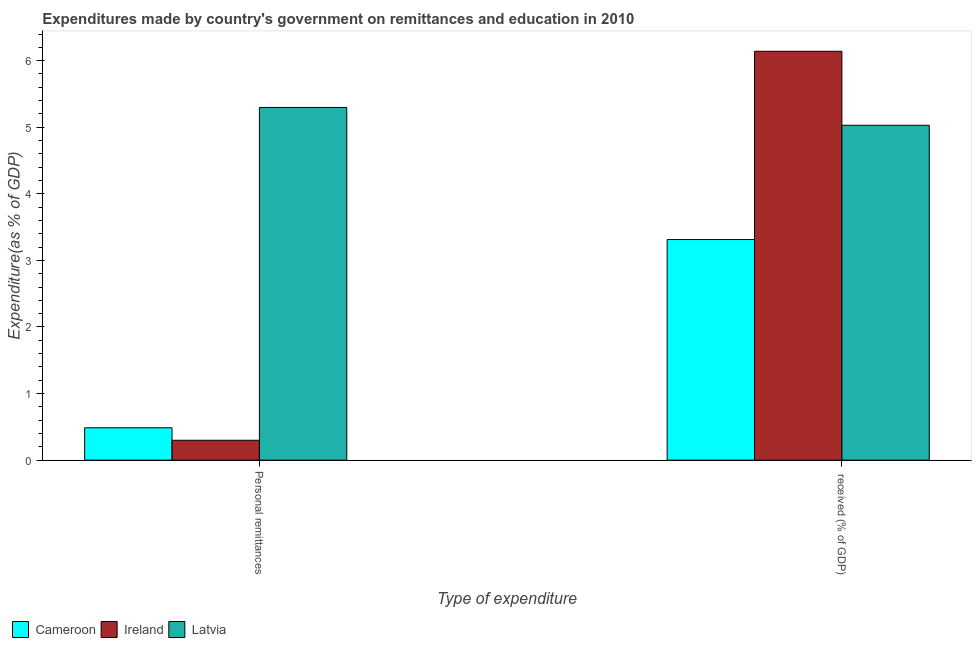How many groups of bars are there?
Offer a terse response. 2. Are the number of bars per tick equal to the number of legend labels?
Make the answer very short. Yes. How many bars are there on the 2nd tick from the left?
Keep it short and to the point. 3. How many bars are there on the 2nd tick from the right?
Offer a very short reply. 3. What is the label of the 1st group of bars from the left?
Your answer should be very brief. Personal remittances. What is the expenditure in education in Latvia?
Provide a short and direct response. 5.03. Across all countries, what is the maximum expenditure in personal remittances?
Offer a terse response. 5.3. Across all countries, what is the minimum expenditure in personal remittances?
Your answer should be very brief. 0.3. In which country was the expenditure in personal remittances maximum?
Your response must be concise. Latvia. In which country was the expenditure in education minimum?
Keep it short and to the point. Cameroon. What is the total expenditure in personal remittances in the graph?
Give a very brief answer. 6.08. What is the difference between the expenditure in personal remittances in Cameroon and that in Latvia?
Make the answer very short. -4.81. What is the difference between the expenditure in personal remittances in Latvia and the expenditure in education in Ireland?
Offer a terse response. -0.84. What is the average expenditure in personal remittances per country?
Make the answer very short. 2.03. What is the difference between the expenditure in education and expenditure in personal remittances in Cameroon?
Keep it short and to the point. 2.83. In how many countries, is the expenditure in personal remittances greater than 3.6 %?
Make the answer very short. 1. What is the ratio of the expenditure in personal remittances in Cameroon to that in Ireland?
Offer a very short reply. 1.63. In how many countries, is the expenditure in education greater than the average expenditure in education taken over all countries?
Keep it short and to the point. 2. What does the 1st bar from the left in Personal remittances represents?
Ensure brevity in your answer.  Cameroon. What does the 3rd bar from the right in Personal remittances represents?
Give a very brief answer. Cameroon. How many bars are there?
Offer a very short reply. 6. Are all the bars in the graph horizontal?
Provide a succinct answer. No. What is the difference between two consecutive major ticks on the Y-axis?
Keep it short and to the point. 1. Are the values on the major ticks of Y-axis written in scientific E-notation?
Provide a short and direct response. No. Does the graph contain any zero values?
Provide a succinct answer. No. Where does the legend appear in the graph?
Provide a short and direct response. Bottom left. How many legend labels are there?
Give a very brief answer. 3. How are the legend labels stacked?
Your answer should be compact. Horizontal. What is the title of the graph?
Offer a very short reply. Expenditures made by country's government on remittances and education in 2010. Does "Burkina Faso" appear as one of the legend labels in the graph?
Give a very brief answer. No. What is the label or title of the X-axis?
Your answer should be compact. Type of expenditure. What is the label or title of the Y-axis?
Provide a short and direct response. Expenditure(as % of GDP). What is the Expenditure(as % of GDP) in Cameroon in Personal remittances?
Provide a short and direct response. 0.49. What is the Expenditure(as % of GDP) of Ireland in Personal remittances?
Keep it short and to the point. 0.3. What is the Expenditure(as % of GDP) of Latvia in Personal remittances?
Provide a short and direct response. 5.3. What is the Expenditure(as % of GDP) of Cameroon in  received (% of GDP)?
Offer a terse response. 3.31. What is the Expenditure(as % of GDP) of Ireland in  received (% of GDP)?
Offer a terse response. 6.14. What is the Expenditure(as % of GDP) in Latvia in  received (% of GDP)?
Your answer should be very brief. 5.03. Across all Type of expenditure, what is the maximum Expenditure(as % of GDP) of Cameroon?
Offer a terse response. 3.31. Across all Type of expenditure, what is the maximum Expenditure(as % of GDP) in Ireland?
Your response must be concise. 6.14. Across all Type of expenditure, what is the maximum Expenditure(as % of GDP) of Latvia?
Keep it short and to the point. 5.3. Across all Type of expenditure, what is the minimum Expenditure(as % of GDP) of Cameroon?
Offer a terse response. 0.49. Across all Type of expenditure, what is the minimum Expenditure(as % of GDP) in Ireland?
Keep it short and to the point. 0.3. Across all Type of expenditure, what is the minimum Expenditure(as % of GDP) of Latvia?
Provide a short and direct response. 5.03. What is the total Expenditure(as % of GDP) of Cameroon in the graph?
Offer a terse response. 3.8. What is the total Expenditure(as % of GDP) of Ireland in the graph?
Offer a very short reply. 6.44. What is the total Expenditure(as % of GDP) in Latvia in the graph?
Ensure brevity in your answer.  10.33. What is the difference between the Expenditure(as % of GDP) in Cameroon in Personal remittances and that in  received (% of GDP)?
Ensure brevity in your answer.  -2.83. What is the difference between the Expenditure(as % of GDP) in Ireland in Personal remittances and that in  received (% of GDP)?
Provide a succinct answer. -5.84. What is the difference between the Expenditure(as % of GDP) of Latvia in Personal remittances and that in  received (% of GDP)?
Offer a very short reply. 0.27. What is the difference between the Expenditure(as % of GDP) of Cameroon in Personal remittances and the Expenditure(as % of GDP) of Ireland in  received (% of GDP)?
Your response must be concise. -5.65. What is the difference between the Expenditure(as % of GDP) in Cameroon in Personal remittances and the Expenditure(as % of GDP) in Latvia in  received (% of GDP)?
Make the answer very short. -4.54. What is the difference between the Expenditure(as % of GDP) of Ireland in Personal remittances and the Expenditure(as % of GDP) of Latvia in  received (% of GDP)?
Keep it short and to the point. -4.73. What is the average Expenditure(as % of GDP) in Cameroon per Type of expenditure?
Your answer should be compact. 1.9. What is the average Expenditure(as % of GDP) in Ireland per Type of expenditure?
Offer a terse response. 3.22. What is the average Expenditure(as % of GDP) of Latvia per Type of expenditure?
Your response must be concise. 5.16. What is the difference between the Expenditure(as % of GDP) in Cameroon and Expenditure(as % of GDP) in Ireland in Personal remittances?
Give a very brief answer. 0.19. What is the difference between the Expenditure(as % of GDP) of Cameroon and Expenditure(as % of GDP) of Latvia in Personal remittances?
Your response must be concise. -4.81. What is the difference between the Expenditure(as % of GDP) in Ireland and Expenditure(as % of GDP) in Latvia in Personal remittances?
Your answer should be very brief. -5. What is the difference between the Expenditure(as % of GDP) of Cameroon and Expenditure(as % of GDP) of Ireland in  received (% of GDP)?
Make the answer very short. -2.83. What is the difference between the Expenditure(as % of GDP) of Cameroon and Expenditure(as % of GDP) of Latvia in  received (% of GDP)?
Offer a terse response. -1.72. What is the difference between the Expenditure(as % of GDP) in Ireland and Expenditure(as % of GDP) in Latvia in  received (% of GDP)?
Your answer should be very brief. 1.11. What is the ratio of the Expenditure(as % of GDP) of Cameroon in Personal remittances to that in  received (% of GDP)?
Provide a short and direct response. 0.15. What is the ratio of the Expenditure(as % of GDP) in Ireland in Personal remittances to that in  received (% of GDP)?
Keep it short and to the point. 0.05. What is the ratio of the Expenditure(as % of GDP) in Latvia in Personal remittances to that in  received (% of GDP)?
Your answer should be very brief. 1.05. What is the difference between the highest and the second highest Expenditure(as % of GDP) of Cameroon?
Provide a succinct answer. 2.83. What is the difference between the highest and the second highest Expenditure(as % of GDP) in Ireland?
Offer a terse response. 5.84. What is the difference between the highest and the second highest Expenditure(as % of GDP) of Latvia?
Your answer should be compact. 0.27. What is the difference between the highest and the lowest Expenditure(as % of GDP) in Cameroon?
Provide a succinct answer. 2.83. What is the difference between the highest and the lowest Expenditure(as % of GDP) in Ireland?
Your answer should be compact. 5.84. What is the difference between the highest and the lowest Expenditure(as % of GDP) in Latvia?
Offer a very short reply. 0.27. 